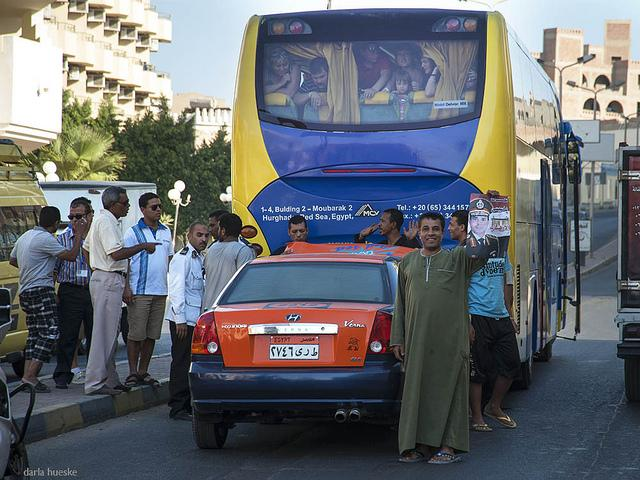What do those gathered look at here?

Choices:
A) tourists
B) protestors
C) car crash
D) markets car crash 